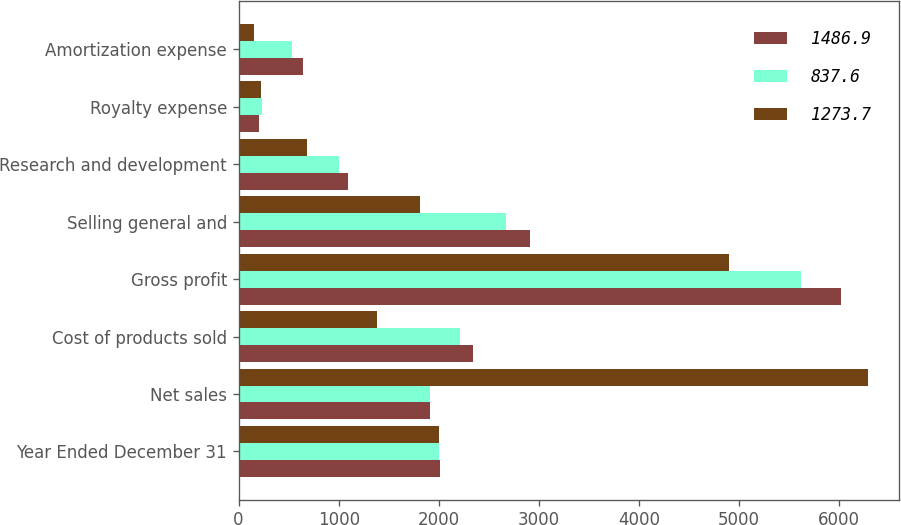Convert chart. <chart><loc_0><loc_0><loc_500><loc_500><stacked_bar_chart><ecel><fcel>Year Ended December 31<fcel>Net sales<fcel>Cost of products sold<fcel>Gross profit<fcel>Selling general and<fcel>Research and development<fcel>Royalty expense<fcel>Amortization expense<nl><fcel>1486.9<fcel>2007<fcel>1909.5<fcel>2342<fcel>6015<fcel>2909<fcel>1091<fcel>202<fcel>641<nl><fcel>837.6<fcel>2006<fcel>1909.5<fcel>2207<fcel>5614<fcel>2675<fcel>1008<fcel>231<fcel>530<nl><fcel>1273.7<fcel>2005<fcel>6283<fcel>1386<fcel>4897<fcel>1814<fcel>680<fcel>227<fcel>152<nl></chart> 